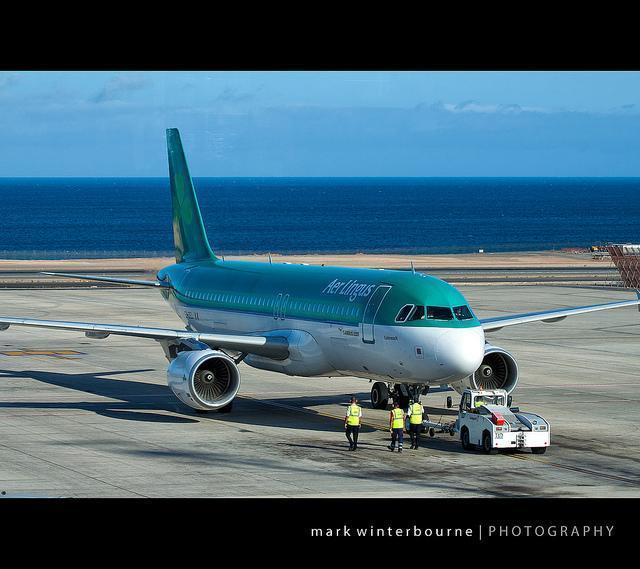How many planes?
Give a very brief answer. 1. How many people are wearing yellow?
Give a very brief answer. 3. How many red chairs are in this image?
Give a very brief answer. 0. 